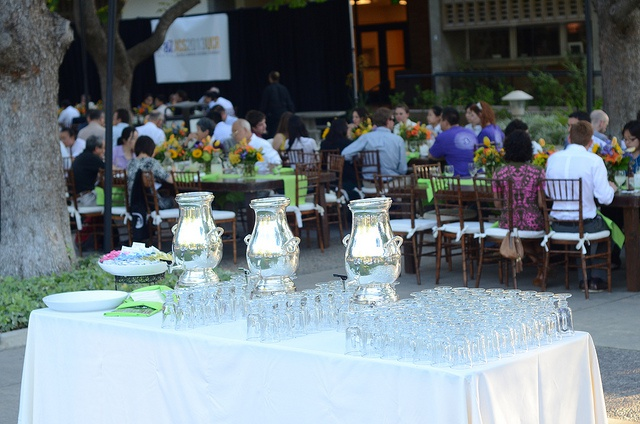Describe the objects in this image and their specific colors. I can see dining table in black, lightblue, and darkgray tones, wine glass in black, lightblue, and darkgray tones, people in black, gray, and darkgray tones, chair in black, darkgray, gray, and lightblue tones, and people in black and purple tones in this image. 